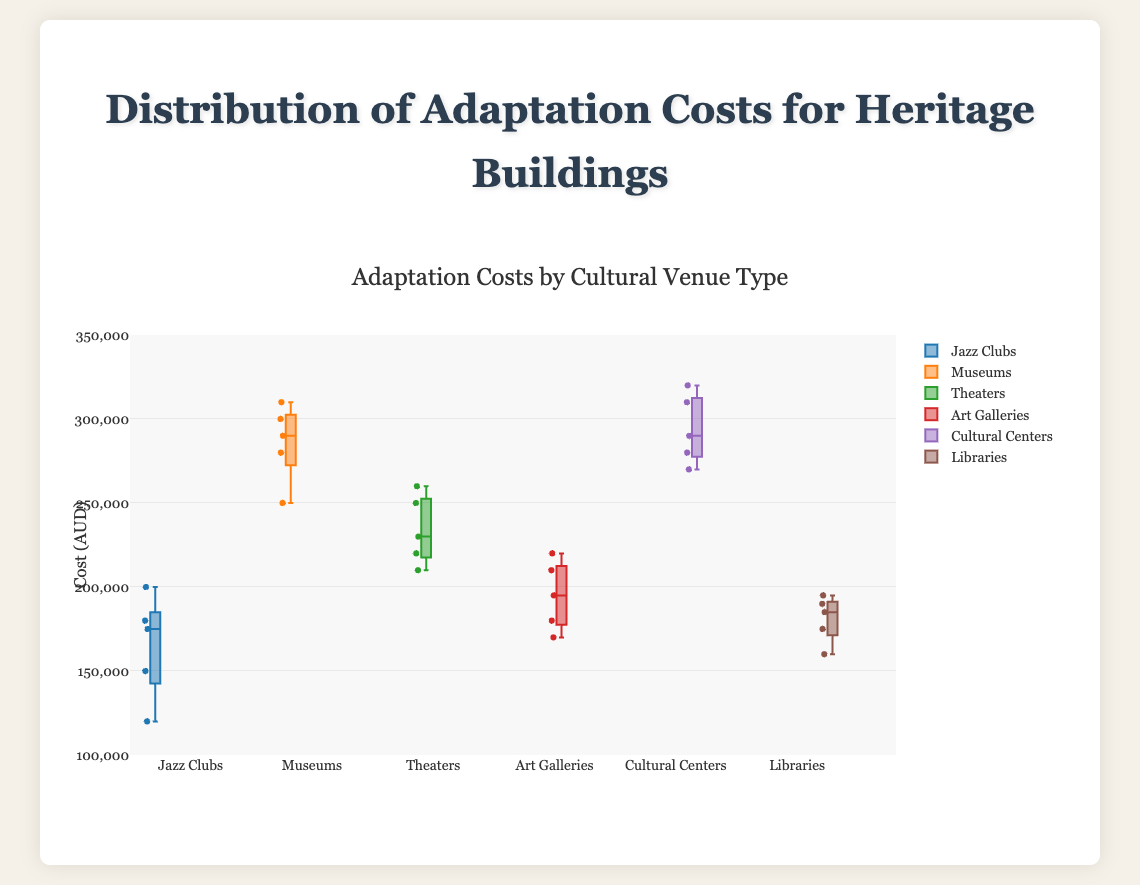What is the title of the figure? The title is located at the top of the figure. It summarizes the data presented in the box plot.
Answer: Distribution of Adaptation Costs for Heritage Buildings Which type of cultural venue has the highest median adaptation cost? The median is typically indicated by a line inside each box. By comparing the median lines, we can determine which one is the highest.
Answer: Museums What is the range of costs for Jazz Clubs? The range can be found by identifying the minimum and maximum values of the whiskers for Jazz Clubs. These whiskers extend from the box to the smallest and largest values.
Answer: 120,000 to 200,000 AUD Which cultural venue has the smallest variability in adaptation costs? Variability can be evaluated by the interquartile range (IQR), which is the distance between the first and third quartiles in the box plot. We need to identify the smallest IQR.
Answer: Libraries Compare the median adaptation costs of Theaters and Art Galleries. Which one is higher? Compare the median lines within the boxes for Theaters and Art Galleries to see which is positioned higher.
Answer: Theaters How many data points are there for each type of cultural venue? The number of data points is given by the number of circles or points displayed for each box plot.
Answer: 5 data points each What are the quartile values for Cultural Centers? The quartiles are represented by the edges of the box. Identify the lower (Q1) and upper (Q3) quartiles of the Cultural Centers box plot.
Answer: Q1 is 270,000 AUD and Q3 is 310,000 AUD Which cultural venue has the highest maximum adaptation cost? The highest maximum is determined by the top whisker amongst all the box plots.
Answer: Cultural Centers Identify which cultural venue types have costs exceeding 300,000 AUD. Observe the data points for each box plot and identify those with values exceeding 300,000 AUD.
Answer: Museums and Cultural Centers Compare the adaptation cost distribution between Jazz Clubs and Libraries. Which has a wider range? The range is the difference between the maximum and minimum values of the whiskers. Calculate this for both Jazz Clubs and Libraries.
Answer: Jazz Clubs 